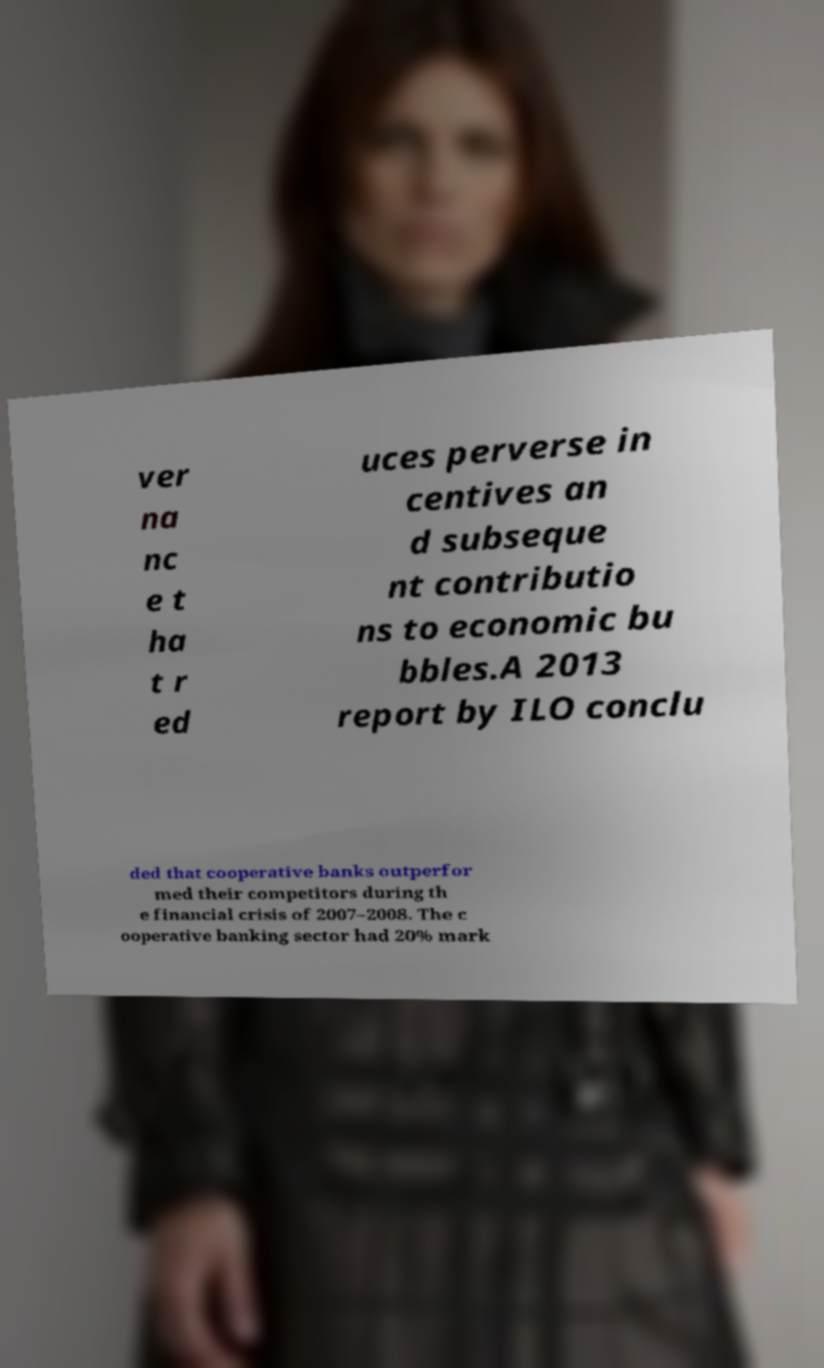Please read and relay the text visible in this image. What does it say? ver na nc e t ha t r ed uces perverse in centives an d subseque nt contributio ns to economic bu bbles.A 2013 report by ILO conclu ded that cooperative banks outperfor med their competitors during th e financial crisis of 2007–2008. The c ooperative banking sector had 20% mark 